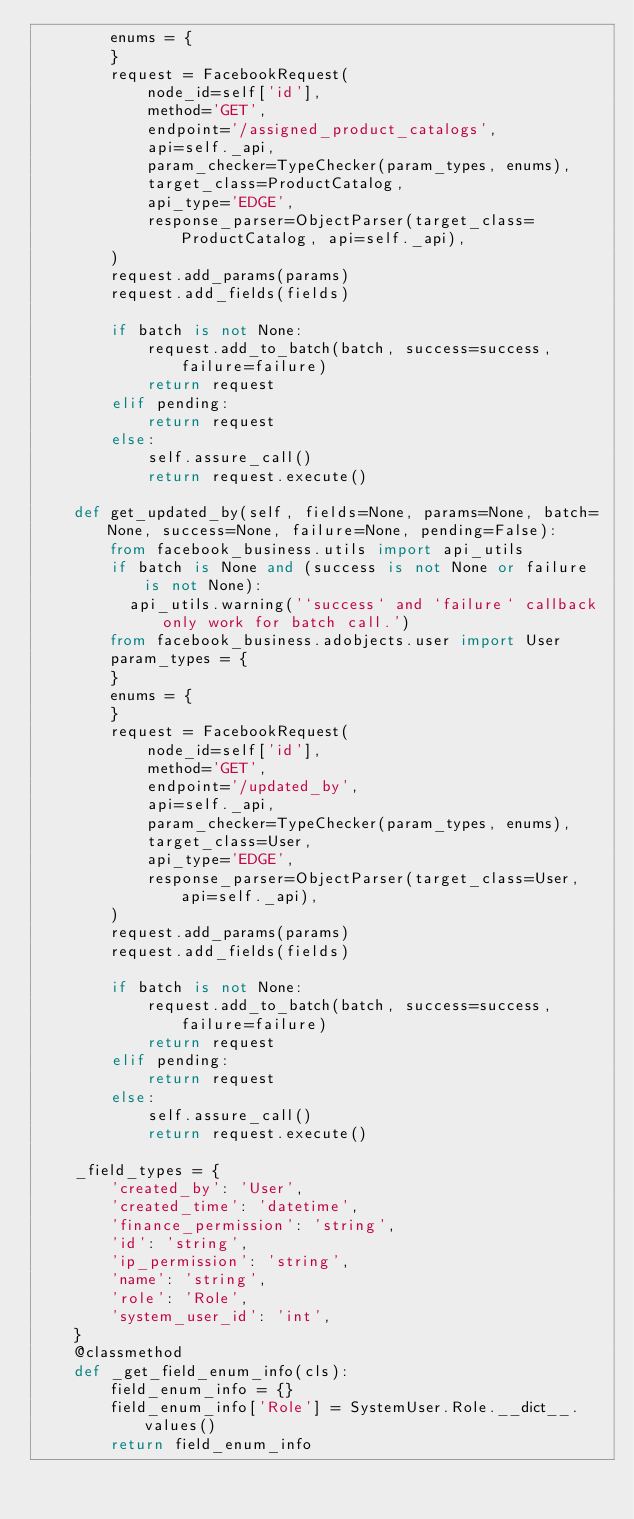Convert code to text. <code><loc_0><loc_0><loc_500><loc_500><_Python_>        enums = {
        }
        request = FacebookRequest(
            node_id=self['id'],
            method='GET',
            endpoint='/assigned_product_catalogs',
            api=self._api,
            param_checker=TypeChecker(param_types, enums),
            target_class=ProductCatalog,
            api_type='EDGE',
            response_parser=ObjectParser(target_class=ProductCatalog, api=self._api),
        )
        request.add_params(params)
        request.add_fields(fields)

        if batch is not None:
            request.add_to_batch(batch, success=success, failure=failure)
            return request
        elif pending:
            return request
        else:
            self.assure_call()
            return request.execute()

    def get_updated_by(self, fields=None, params=None, batch=None, success=None, failure=None, pending=False):
        from facebook_business.utils import api_utils
        if batch is None and (success is not None or failure is not None):
          api_utils.warning('`success` and `failure` callback only work for batch call.')
        from facebook_business.adobjects.user import User
        param_types = {
        }
        enums = {
        }
        request = FacebookRequest(
            node_id=self['id'],
            method='GET',
            endpoint='/updated_by',
            api=self._api,
            param_checker=TypeChecker(param_types, enums),
            target_class=User,
            api_type='EDGE',
            response_parser=ObjectParser(target_class=User, api=self._api),
        )
        request.add_params(params)
        request.add_fields(fields)

        if batch is not None:
            request.add_to_batch(batch, success=success, failure=failure)
            return request
        elif pending:
            return request
        else:
            self.assure_call()
            return request.execute()

    _field_types = {
        'created_by': 'User',
        'created_time': 'datetime',
        'finance_permission': 'string',
        'id': 'string',
        'ip_permission': 'string',
        'name': 'string',
        'role': 'Role',
        'system_user_id': 'int',
    }
    @classmethod
    def _get_field_enum_info(cls):
        field_enum_info = {}
        field_enum_info['Role'] = SystemUser.Role.__dict__.values()
        return field_enum_info


</code> 